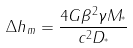<formula> <loc_0><loc_0><loc_500><loc_500>\Delta h _ { m } = \frac { 4 G \beta ^ { 2 } \gamma M _ { ^ { * } } } { c ^ { 2 } D _ { ^ { * } } }</formula> 